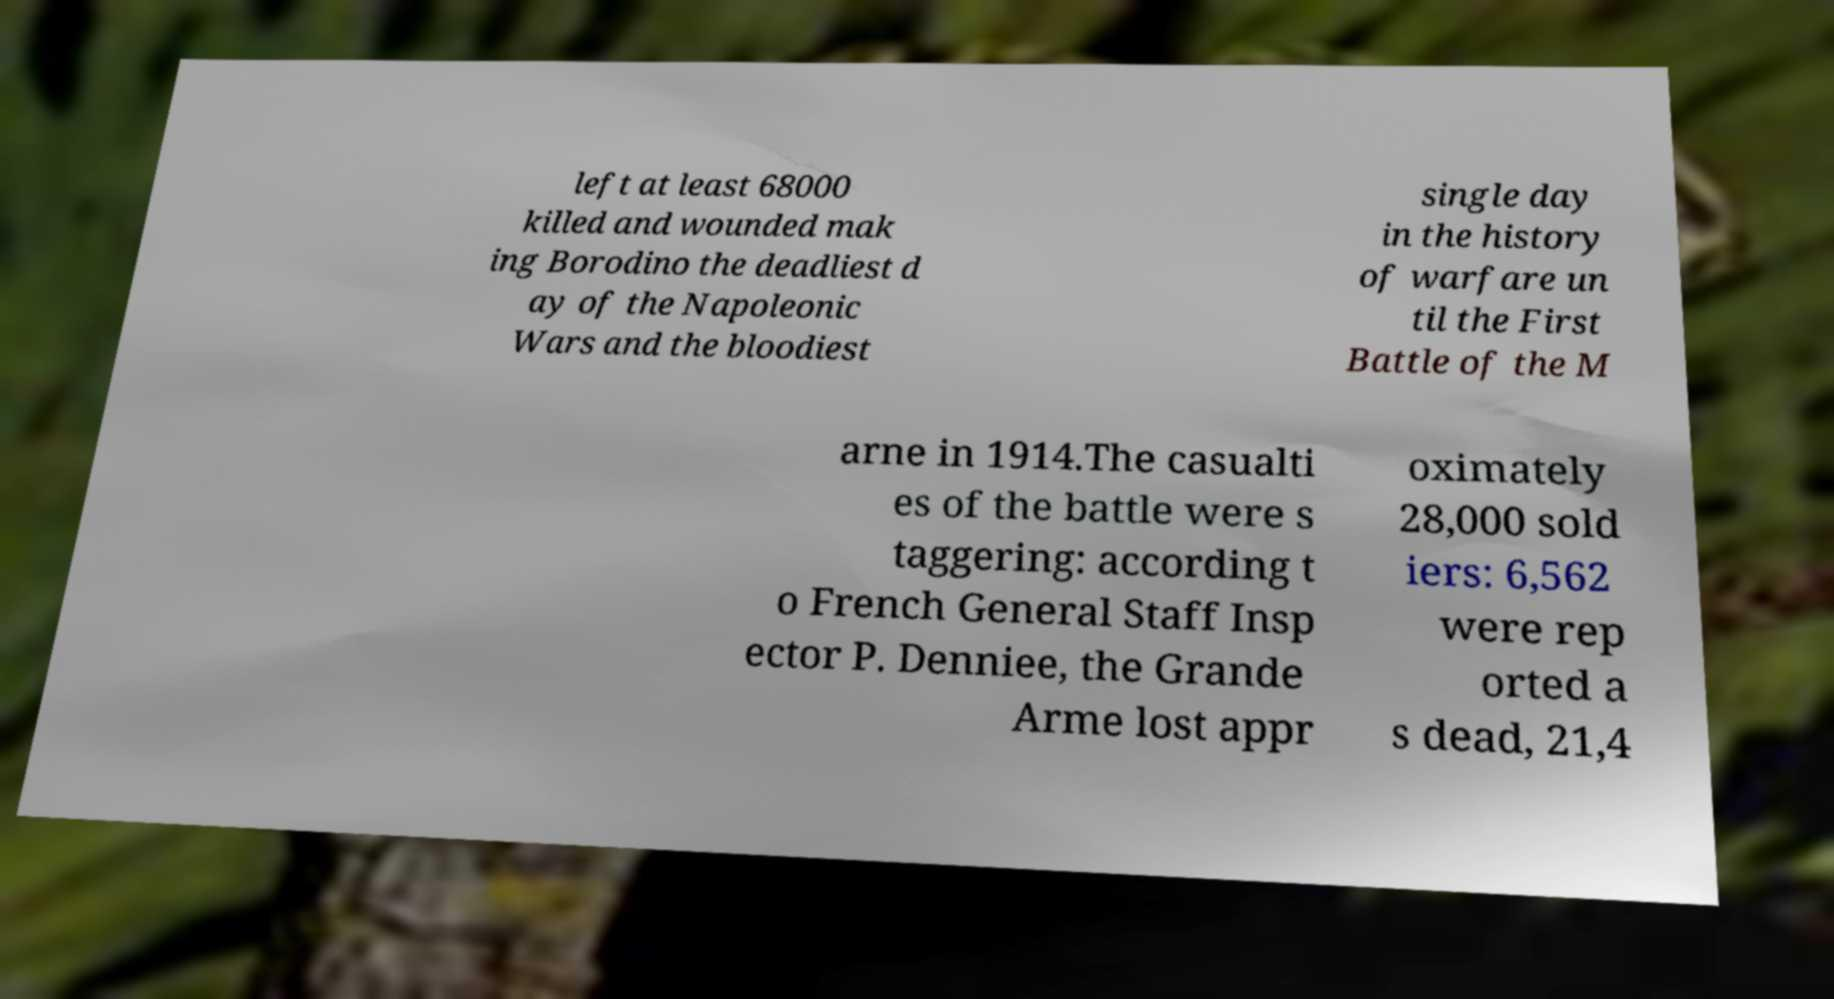I need the written content from this picture converted into text. Can you do that? left at least 68000 killed and wounded mak ing Borodino the deadliest d ay of the Napoleonic Wars and the bloodiest single day in the history of warfare un til the First Battle of the M arne in 1914.The casualti es of the battle were s taggering: according t o French General Staff Insp ector P. Denniee, the Grande Arme lost appr oximately 28,000 sold iers: 6,562 were rep orted a s dead, 21,4 